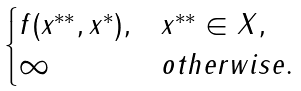Convert formula to latex. <formula><loc_0><loc_0><loc_500><loc_500>\begin{cases} f ( x ^ { * * } , x ^ { * } ) , & x ^ { * * } \in X , \\ \infty & o t h e r w i s e . \end{cases}</formula> 